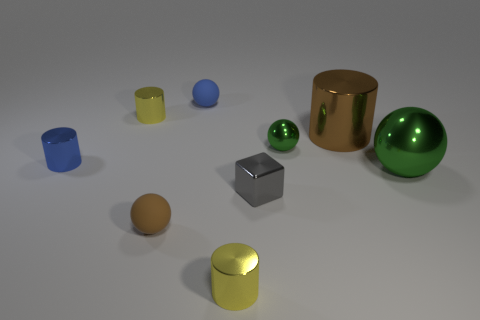There is a green sphere that is the same size as the brown metal thing; what is its material?
Your answer should be compact. Metal. Is there a yellow cylinder that has the same material as the large green ball?
Offer a terse response. Yes. There is a ball that is both right of the tiny gray object and left of the big green thing; what color is it?
Ensure brevity in your answer.  Green. How many other things are there of the same color as the big shiny cylinder?
Give a very brief answer. 1. There is a tiny blue object on the left side of the tiny rubber ball that is in front of the green metal object right of the large cylinder; what is it made of?
Provide a succinct answer. Metal. How many blocks are either small yellow things or small gray shiny things?
Keep it short and to the point. 1. Is there anything else that is the same size as the blue cylinder?
Offer a terse response. Yes. There is a tiny metal thing left of the yellow shiny object that is behind the small brown ball; what number of tiny yellow shiny objects are on the right side of it?
Offer a terse response. 2. Do the brown metallic object and the tiny gray object have the same shape?
Your answer should be very brief. No. Does the tiny sphere that is on the left side of the tiny blue sphere have the same material as the tiny yellow object that is behind the brown matte ball?
Ensure brevity in your answer.  No. 